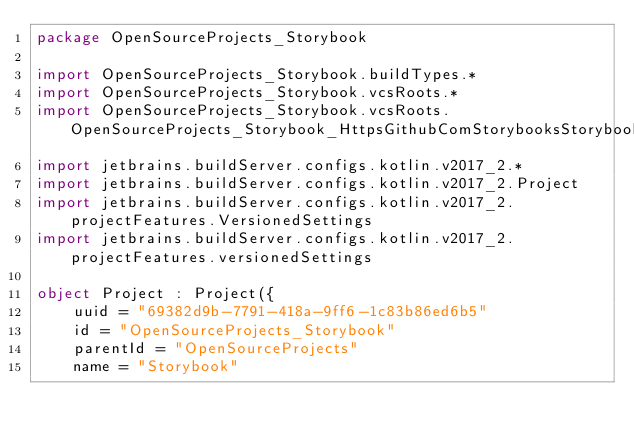<code> <loc_0><loc_0><loc_500><loc_500><_Kotlin_>package OpenSourceProjects_Storybook

import OpenSourceProjects_Storybook.buildTypes.*
import OpenSourceProjects_Storybook.vcsRoots.*
import OpenSourceProjects_Storybook.vcsRoots.OpenSourceProjects_Storybook_HttpsGithubComStorybooksStorybookRefsHeadsMaster
import jetbrains.buildServer.configs.kotlin.v2017_2.*
import jetbrains.buildServer.configs.kotlin.v2017_2.Project
import jetbrains.buildServer.configs.kotlin.v2017_2.projectFeatures.VersionedSettings
import jetbrains.buildServer.configs.kotlin.v2017_2.projectFeatures.versionedSettings

object Project : Project({
    uuid = "69382d9b-7791-418a-9ff6-1c83b86ed6b5"
    id = "OpenSourceProjects_Storybook"
    parentId = "OpenSourceProjects"
    name = "Storybook"</code> 